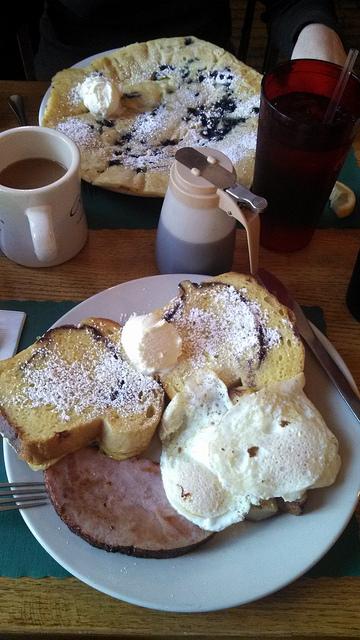What is decorated with icing sugar?
Answer briefly. French toast. What beverage is in the mug?
Give a very brief answer. Coffee. Is this a dinner  party?
Write a very short answer. No. Is this a vegetarian meal?
Give a very brief answer. No. Is there butter on the bread?
Concise answer only. Yes. What is the white stuff on the plate?
Give a very brief answer. Eggs. 